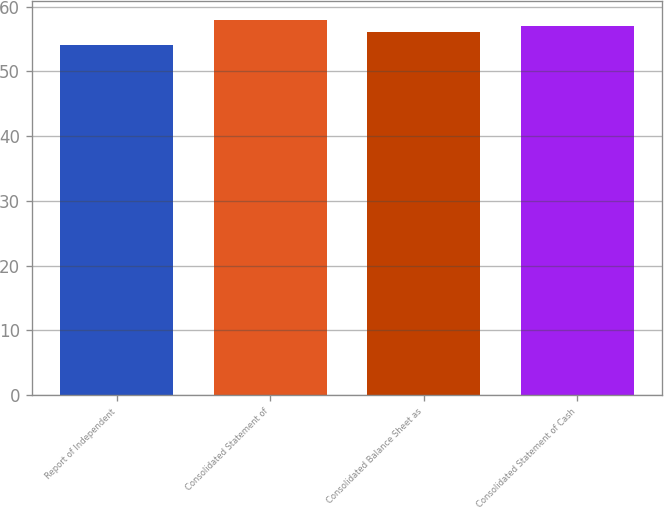Convert chart. <chart><loc_0><loc_0><loc_500><loc_500><bar_chart><fcel>Report of Independent<fcel>Consolidated Statement of<fcel>Consolidated Balance Sheet as<fcel>Consolidated Statement of Cash<nl><fcel>54<fcel>58<fcel>56<fcel>57<nl></chart> 